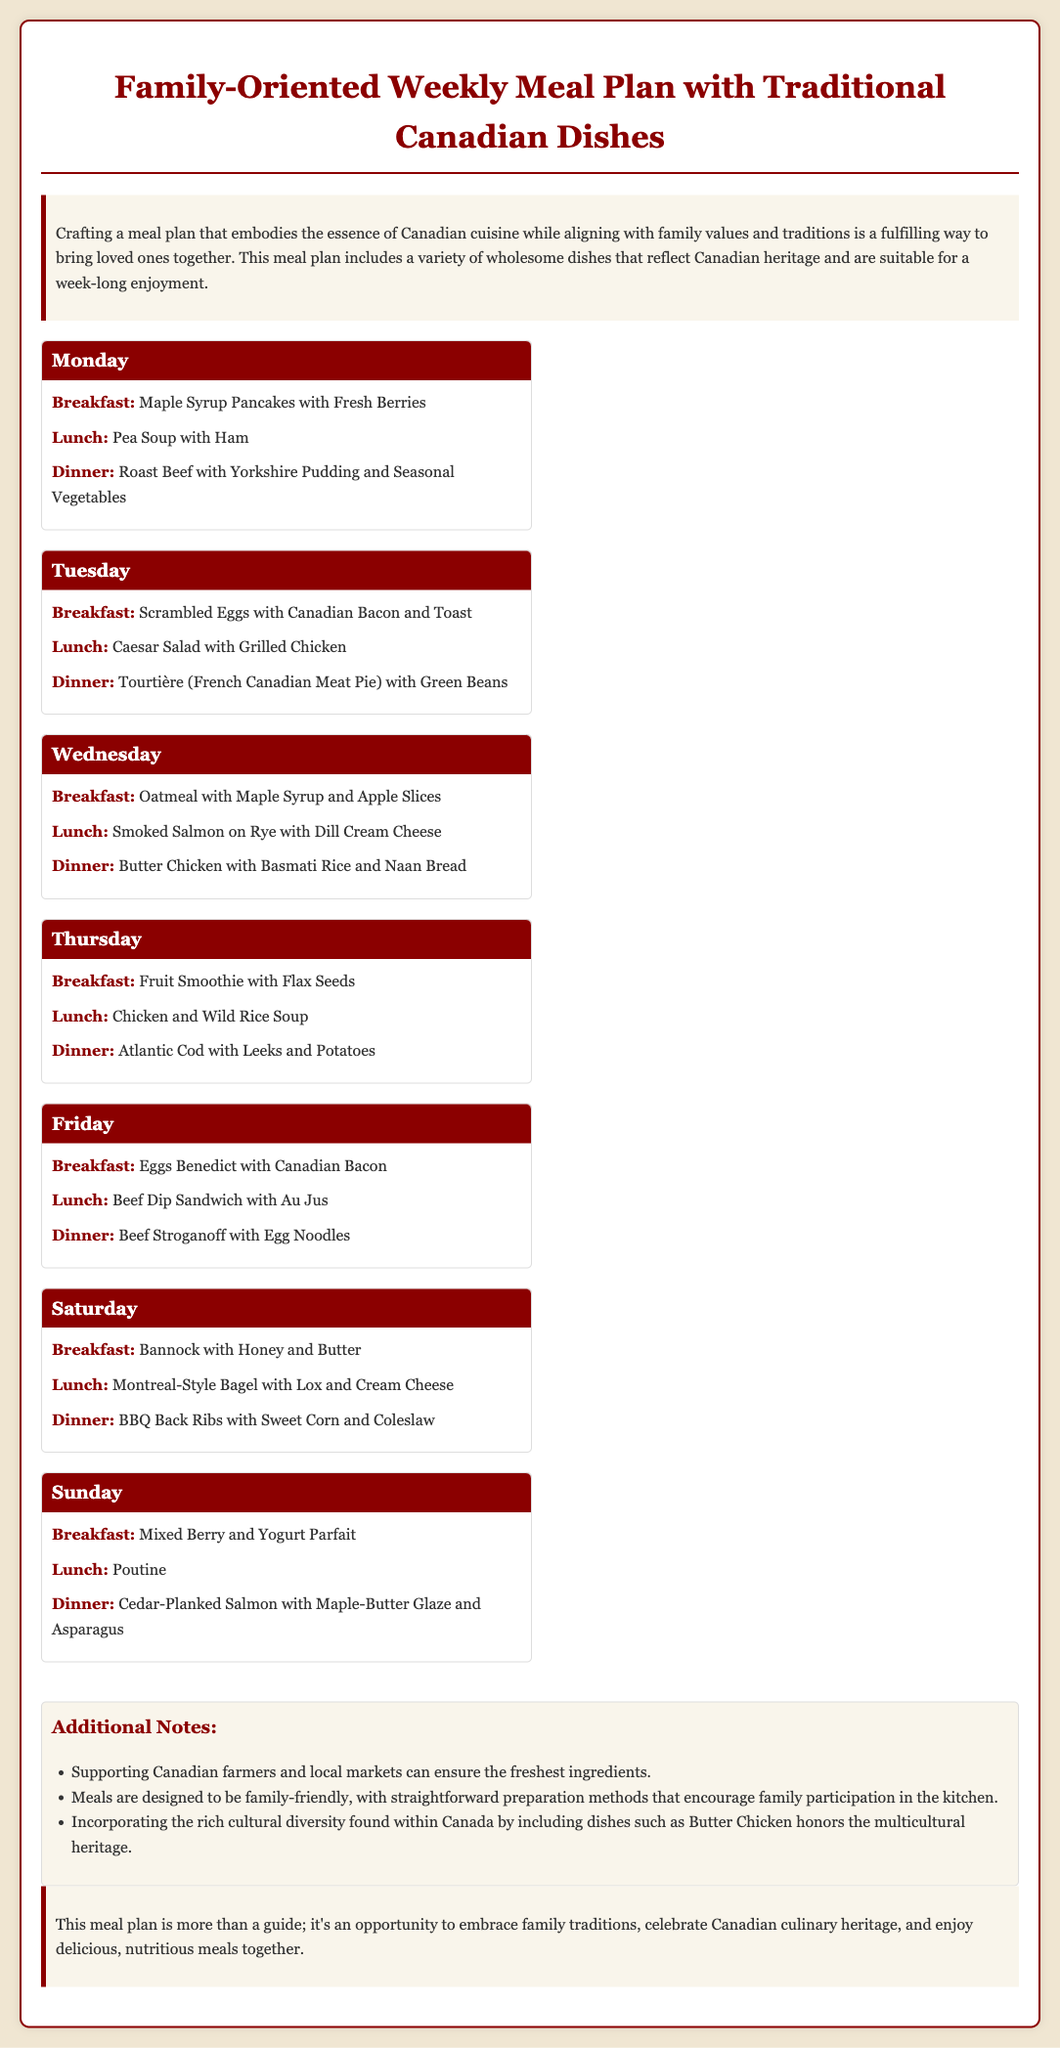What is the title of the meal plan? The title is stated in the header of the document, emphasizing the family-oriented aspect and traditional Canadian dishes.
Answer: Family-Oriented Weekly Meal Plan with Traditional Canadian Dishes How many meals are listed for each day? Each day features three meals: breakfast, lunch, and dinner.
Answer: Three What traditional dish is served on Tuesday for dinner? The document specifies the meal for Tuesday dinner as a traditional French Canadian dish.
Answer: Tourtière Which fruit is mentioned in the Monday breakfast? The meal plan includes fresh produce highlighted in the breakfast section for Monday.
Answer: Fresh Berries What type of fish is featured in the Sunday dinner? The document refers to a specific preparation method for the fish dish served on Sunday.
Answer: Salmon How many days are included in the meal plan? The whole week of meals is outlined, covering breakfast, lunch, and dinner for each day.
Answer: Seven What is suggested to support during meal preparation? The document mentions a practice that connects meals with community and freshness.
Answer: Canadian farmers On which day are Eggs Benedict served? The specific day for this traditional breakfast dish is highlighted in the meal plan.
Answer: Friday What is included in the notes section? The notes section provides additional information relevant to meal preparation and sourcing.
Answer: Supporting Canadian farmers and local markets 